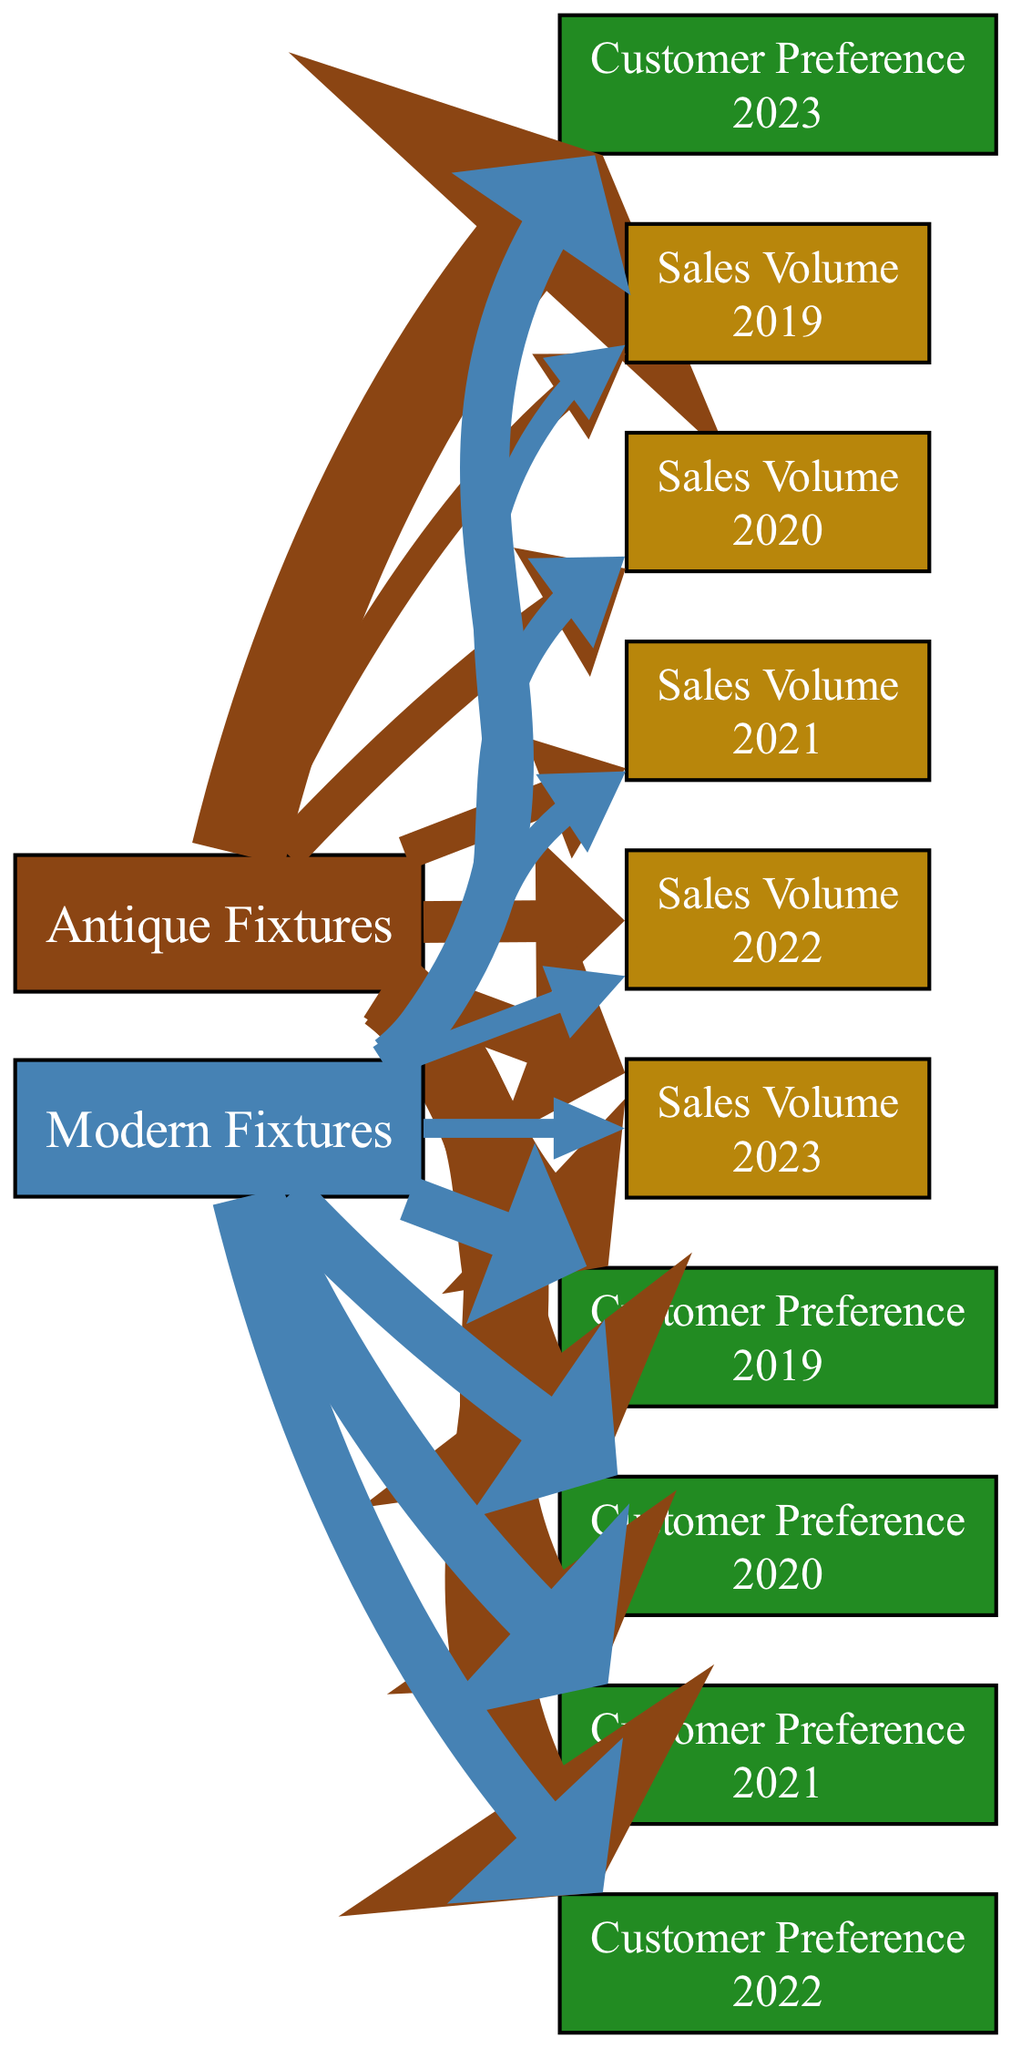What is the highest customer preference value for Antique Fixtures? The edges connected to the "Customer Preference" nodes for "Antique Fixtures" reveal the values. The highest value in 2023 is 250, occurring at the edge linking "Antique Fixtures" to "Customer Preference 2023."
Answer: 250 What was the sales volume for Modern Fixtures in 2020? Referring to the edge from "Modern Fixtures" to "Sales Volume 2020," the value indicated is 80.
Answer: 80 How many nodes represent customer preference over the five years? The "Customer Preference" nodes are present for each of the five years (2019 to 2023), totaling five nodes in the diagram.
Answer: 5 Which type of fixtures had a higher customer preference in 2022? By comparing the values from the edges for both fixture types, "Antique Fixtures" had a preference value of 210, while "Modern Fixtures" had 140. Antique Fixtures had a higher preference.
Answer: Antique Fixtures What is the total sales volume for Antique Fixtures over the five years? Adding all the values from the edges linked to "Sales Volume" for "Antique Fixtures" gives: 75 + 100 + 90 + 110 + 130 = 505.
Answer: 505 In which year did Modern Fixtures see their lowest customer preference? Evaluating the edges leading to "Customer Preference" for "Modern Fixtures," the data shows 120 in 2019, rising and falling thereafter, with the lowest preference being 130 in 2023.
Answer: 2023 What percentage of customer preference did Modern Fixtures have in 2021 compared to Antique Fixtures? For 2021, Modern Fixtures had 160, while Antique Fixtures had 180. The percentage is calculated as (160/180)*100, resulting in approximately 88.89%.
Answer: 88.89% Which category had an increase in sales volume from 2019 to 2023? Examining the sales volume values reveals that "Antique Fixtures" increased from 75 in 2019 to 130 in 2023, while "Modern Fixtures" decreased from 60 to 50. Therefore, only Antique Fixtures had an increase.
Answer: Antique Fixtures 